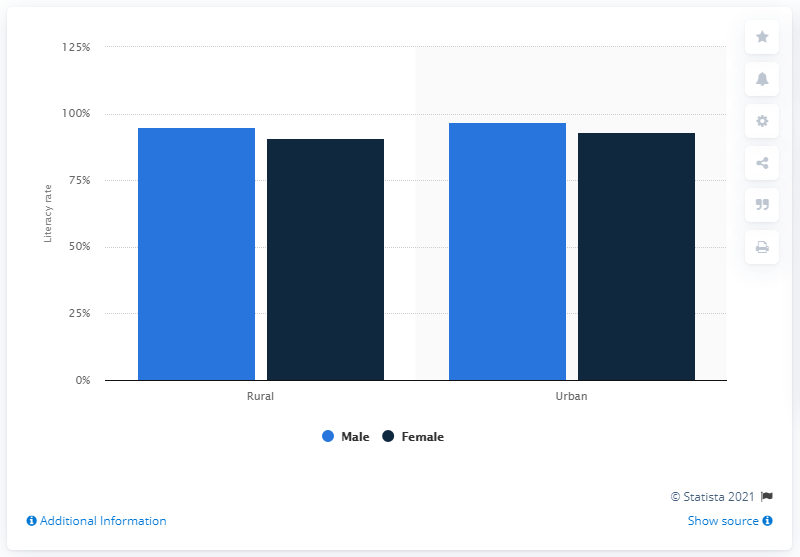Identify some key points in this picture. According to data from 2011, the literacy rate among males living in rural areas in Kerala was 95%. 